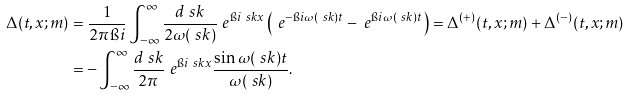Convert formula to latex. <formula><loc_0><loc_0><loc_500><loc_500>\Delta ( t , x ; m ) & = \frac { 1 } { 2 \pi \i i } \int _ { - \infty } ^ { \infty } \frac { d \ s k } { 2 \omega ( \ s k ) } \ e ^ { \i i \ s k x } \left ( \ e ^ { - \i i \omega ( \ s k ) t } - \ e ^ { \i i \omega ( \ s k ) t } \right ) = \Delta ^ { ( + ) } ( t , x ; m ) + \Delta ^ { ( - ) } ( t , x ; m ) \\ & = - \int _ { - \infty } ^ { \infty } \frac { d \ s k } { 2 \pi } \ e ^ { \i i \ s k x } \frac { \sin \omega ( \ s k ) t } { \omega ( \ s k ) } .</formula> 